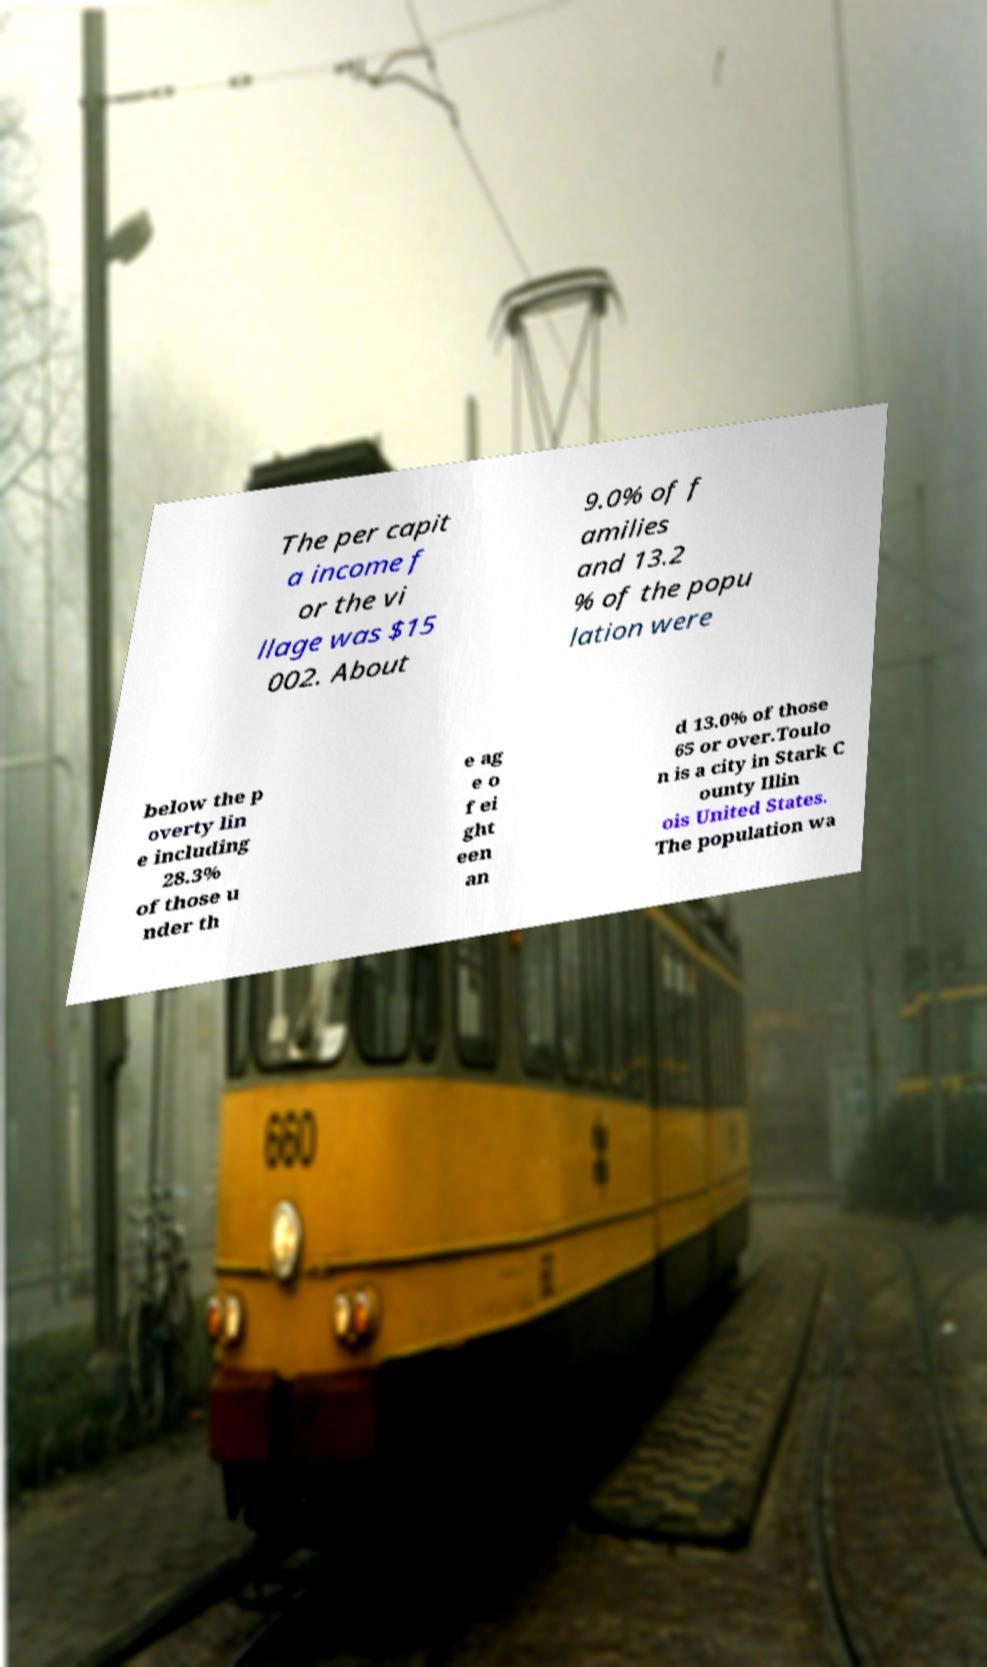Can you read and provide the text displayed in the image?This photo seems to have some interesting text. Can you extract and type it out for me? The per capit a income f or the vi llage was $15 002. About 9.0% of f amilies and 13.2 % of the popu lation were below the p overty lin e including 28.3% of those u nder th e ag e o f ei ght een an d 13.0% of those 65 or over.Toulo n is a city in Stark C ounty Illin ois United States. The population wa 